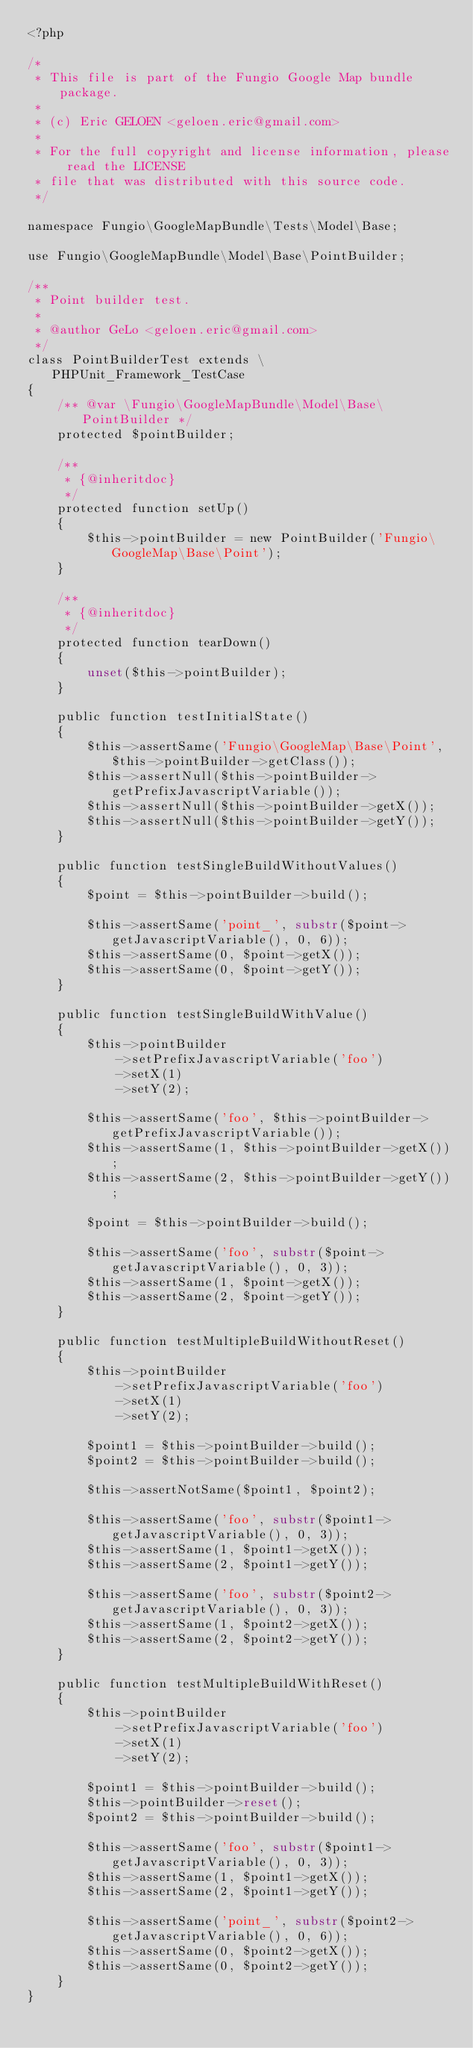Convert code to text. <code><loc_0><loc_0><loc_500><loc_500><_PHP_><?php

/*
 * This file is part of the Fungio Google Map bundle package.
 *
 * (c) Eric GELOEN <geloen.eric@gmail.com>
 *
 * For the full copyright and license information, please read the LICENSE
 * file that was distributed with this source code.
 */

namespace Fungio\GoogleMapBundle\Tests\Model\Base;

use Fungio\GoogleMapBundle\Model\Base\PointBuilder;

/**
 * Point builder test.
 *
 * @author GeLo <geloen.eric@gmail.com>
 */
class PointBuilderTest extends \PHPUnit_Framework_TestCase
{
    /** @var \Fungio\GoogleMapBundle\Model\Base\PointBuilder */
    protected $pointBuilder;

    /**
     * {@inheritdoc}
     */
    protected function setUp()
    {
        $this->pointBuilder = new PointBuilder('Fungio\GoogleMap\Base\Point');
    }

    /**
     * {@inheritdoc}
     */
    protected function tearDown()
    {
        unset($this->pointBuilder);
    }

    public function testInitialState()
    {
        $this->assertSame('Fungio\GoogleMap\Base\Point', $this->pointBuilder->getClass());
        $this->assertNull($this->pointBuilder->getPrefixJavascriptVariable());
        $this->assertNull($this->pointBuilder->getX());
        $this->assertNull($this->pointBuilder->getY());
    }

    public function testSingleBuildWithoutValues()
    {
        $point = $this->pointBuilder->build();

        $this->assertSame('point_', substr($point->getJavascriptVariable(), 0, 6));
        $this->assertSame(0, $point->getX());
        $this->assertSame(0, $point->getY());
    }

    public function testSingleBuildWithValue()
    {
        $this->pointBuilder
            ->setPrefixJavascriptVariable('foo')
            ->setX(1)
            ->setY(2);

        $this->assertSame('foo', $this->pointBuilder->getPrefixJavascriptVariable());
        $this->assertSame(1, $this->pointBuilder->getX());
        $this->assertSame(2, $this->pointBuilder->getY());

        $point = $this->pointBuilder->build();

        $this->assertSame('foo', substr($point->getJavascriptVariable(), 0, 3));
        $this->assertSame(1, $point->getX());
        $this->assertSame(2, $point->getY());
    }

    public function testMultipleBuildWithoutReset()
    {
        $this->pointBuilder
            ->setPrefixJavascriptVariable('foo')
            ->setX(1)
            ->setY(2);

        $point1 = $this->pointBuilder->build();
        $point2 = $this->pointBuilder->build();

        $this->assertNotSame($point1, $point2);

        $this->assertSame('foo', substr($point1->getJavascriptVariable(), 0, 3));
        $this->assertSame(1, $point1->getX());
        $this->assertSame(2, $point1->getY());

        $this->assertSame('foo', substr($point2->getJavascriptVariable(), 0, 3));
        $this->assertSame(1, $point2->getX());
        $this->assertSame(2, $point2->getY());
    }

    public function testMultipleBuildWithReset()
    {
        $this->pointBuilder
            ->setPrefixJavascriptVariable('foo')
            ->setX(1)
            ->setY(2);

        $point1 = $this->pointBuilder->build();
        $this->pointBuilder->reset();
        $point2 = $this->pointBuilder->build();

        $this->assertSame('foo', substr($point1->getJavascriptVariable(), 0, 3));
        $this->assertSame(1, $point1->getX());
        $this->assertSame(2, $point1->getY());

        $this->assertSame('point_', substr($point2->getJavascriptVariable(), 0, 6));
        $this->assertSame(0, $point2->getX());
        $this->assertSame(0, $point2->getY());
    }
}
</code> 